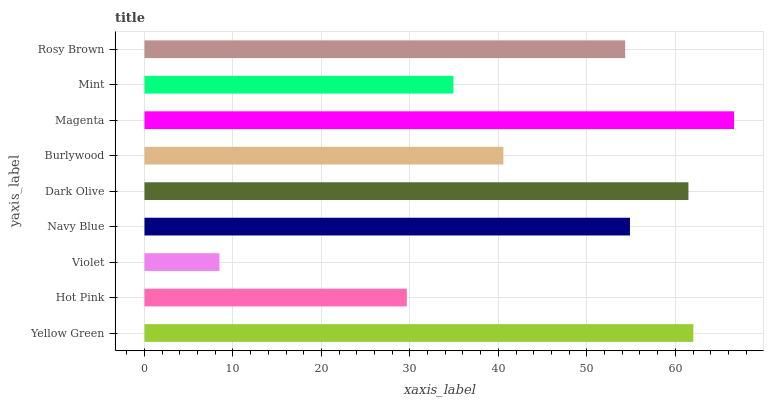Is Violet the minimum?
Answer yes or no. Yes. Is Magenta the maximum?
Answer yes or no. Yes. Is Hot Pink the minimum?
Answer yes or no. No. Is Hot Pink the maximum?
Answer yes or no. No. Is Yellow Green greater than Hot Pink?
Answer yes or no. Yes. Is Hot Pink less than Yellow Green?
Answer yes or no. Yes. Is Hot Pink greater than Yellow Green?
Answer yes or no. No. Is Yellow Green less than Hot Pink?
Answer yes or no. No. Is Rosy Brown the high median?
Answer yes or no. Yes. Is Rosy Brown the low median?
Answer yes or no. Yes. Is Mint the high median?
Answer yes or no. No. Is Mint the low median?
Answer yes or no. No. 